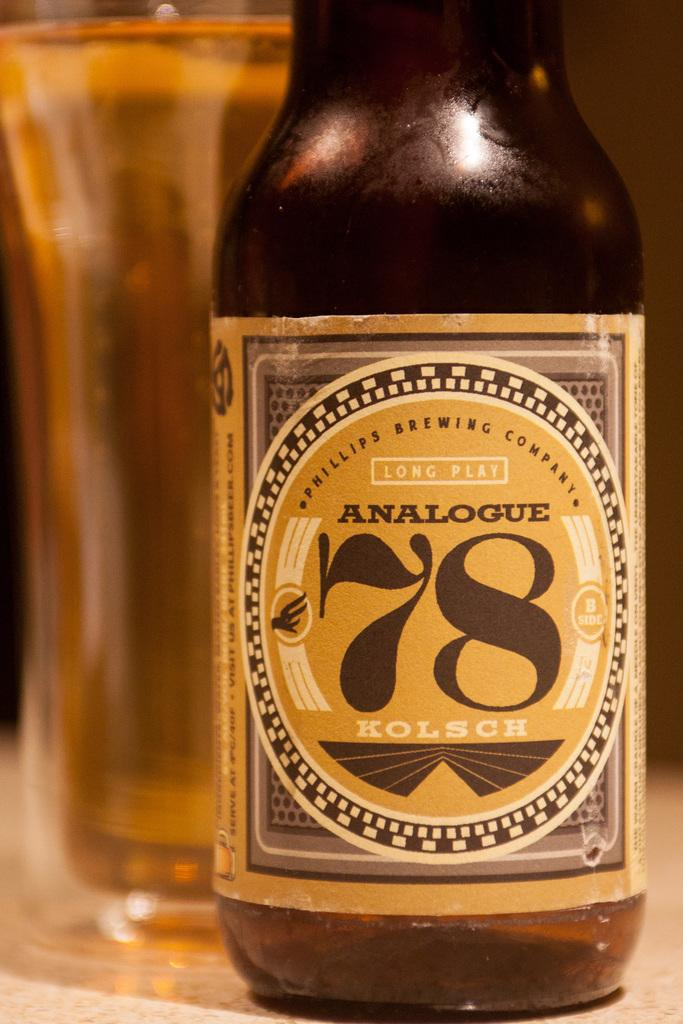<image>
Describe the image concisely. A bottle of long play analogue 78 kolsch liquor 